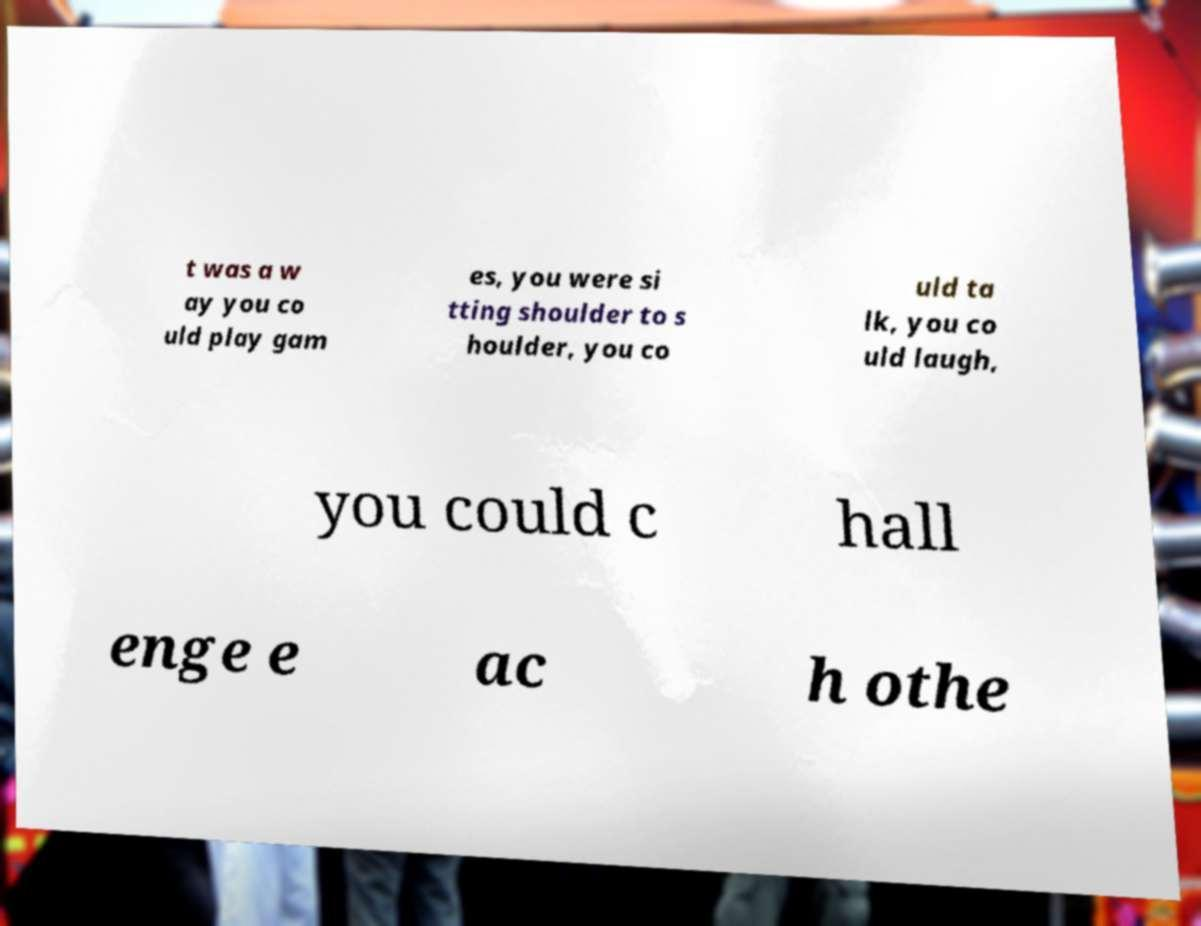Could you extract and type out the text from this image? t was a w ay you co uld play gam es, you were si tting shoulder to s houlder, you co uld ta lk, you co uld laugh, you could c hall enge e ac h othe 